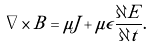Convert formula to latex. <formula><loc_0><loc_0><loc_500><loc_500>\nabla \times B = \mu J + \mu \epsilon { \frac { \partial E } { \partial t } } .</formula> 